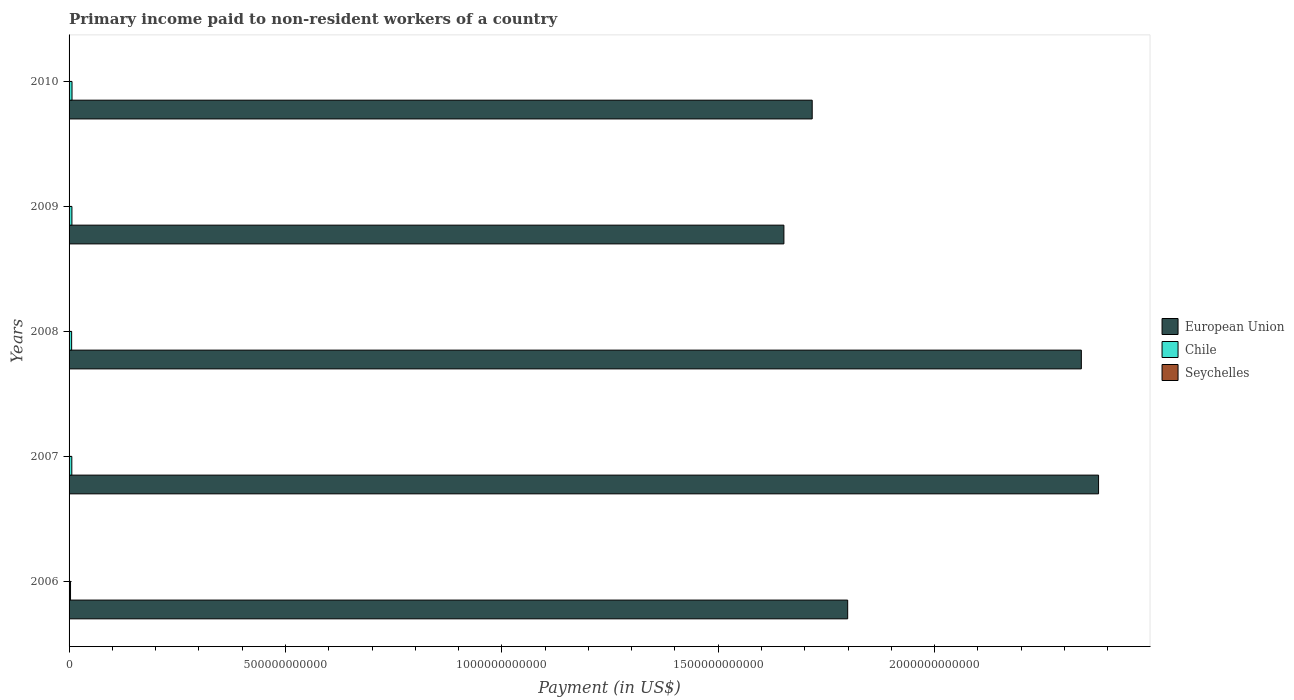How many different coloured bars are there?
Your answer should be compact. 3. How many groups of bars are there?
Make the answer very short. 5. Are the number of bars per tick equal to the number of legend labels?
Make the answer very short. Yes. How many bars are there on the 5th tick from the bottom?
Provide a succinct answer. 3. In how many cases, is the number of bars for a given year not equal to the number of legend labels?
Ensure brevity in your answer.  0. What is the amount paid to workers in Chile in 2010?
Your answer should be compact. 6.80e+09. Across all years, what is the maximum amount paid to workers in Seychelles?
Make the answer very short. 1.03e+07. Across all years, what is the minimum amount paid to workers in Chile?
Provide a short and direct response. 3.37e+09. In which year was the amount paid to workers in Chile maximum?
Ensure brevity in your answer.  2010. In which year was the amount paid to workers in Seychelles minimum?
Offer a very short reply. 2007. What is the total amount paid to workers in European Union in the graph?
Your response must be concise. 9.89e+12. What is the difference between the amount paid to workers in Chile in 2006 and that in 2007?
Your answer should be compact. -2.95e+09. What is the difference between the amount paid to workers in Seychelles in 2009 and the amount paid to workers in Chile in 2008?
Your answer should be very brief. -5.92e+09. What is the average amount paid to workers in Chile per year?
Offer a terse response. 5.80e+09. In the year 2010, what is the difference between the amount paid to workers in Seychelles and amount paid to workers in Chile?
Your response must be concise. -6.79e+09. What is the ratio of the amount paid to workers in Seychelles in 2007 to that in 2010?
Offer a very short reply. 0.37. Is the amount paid to workers in Seychelles in 2007 less than that in 2008?
Ensure brevity in your answer.  Yes. Is the difference between the amount paid to workers in Seychelles in 2008 and 2009 greater than the difference between the amount paid to workers in Chile in 2008 and 2009?
Provide a succinct answer. Yes. What is the difference between the highest and the second highest amount paid to workers in European Union?
Your answer should be very brief. 3.98e+1. What is the difference between the highest and the lowest amount paid to workers in European Union?
Your answer should be compact. 7.27e+11. In how many years, is the amount paid to workers in Seychelles greater than the average amount paid to workers in Seychelles taken over all years?
Keep it short and to the point. 2. What does the 3rd bar from the top in 2008 represents?
Your answer should be very brief. European Union. What does the 2nd bar from the bottom in 2010 represents?
Offer a terse response. Chile. How many years are there in the graph?
Offer a terse response. 5. What is the difference between two consecutive major ticks on the X-axis?
Offer a very short reply. 5.00e+11. Are the values on the major ticks of X-axis written in scientific E-notation?
Offer a very short reply. No. Does the graph contain any zero values?
Offer a terse response. No. Where does the legend appear in the graph?
Your answer should be very brief. Center right. What is the title of the graph?
Make the answer very short. Primary income paid to non-resident workers of a country. What is the label or title of the X-axis?
Your answer should be compact. Payment (in US$). What is the Payment (in US$) of European Union in 2006?
Offer a terse response. 1.80e+12. What is the Payment (in US$) of Chile in 2006?
Provide a short and direct response. 3.37e+09. What is the Payment (in US$) in Seychelles in 2006?
Provide a short and direct response. 1.03e+07. What is the Payment (in US$) of European Union in 2007?
Keep it short and to the point. 2.38e+12. What is the Payment (in US$) of Chile in 2007?
Provide a short and direct response. 6.32e+09. What is the Payment (in US$) in Seychelles in 2007?
Provide a short and direct response. 3.58e+06. What is the Payment (in US$) of European Union in 2008?
Provide a succinct answer. 2.34e+12. What is the Payment (in US$) in Chile in 2008?
Make the answer very short. 5.93e+09. What is the Payment (in US$) of Seychelles in 2008?
Ensure brevity in your answer.  4.88e+06. What is the Payment (in US$) of European Union in 2009?
Offer a very short reply. 1.65e+12. What is the Payment (in US$) of Chile in 2009?
Give a very brief answer. 6.57e+09. What is the Payment (in US$) of Seychelles in 2009?
Your answer should be compact. 3.65e+06. What is the Payment (in US$) of European Union in 2010?
Offer a very short reply. 1.72e+12. What is the Payment (in US$) of Chile in 2010?
Your answer should be compact. 6.80e+09. What is the Payment (in US$) of Seychelles in 2010?
Provide a succinct answer. 9.57e+06. Across all years, what is the maximum Payment (in US$) of European Union?
Your answer should be very brief. 2.38e+12. Across all years, what is the maximum Payment (in US$) in Chile?
Provide a short and direct response. 6.80e+09. Across all years, what is the maximum Payment (in US$) of Seychelles?
Your response must be concise. 1.03e+07. Across all years, what is the minimum Payment (in US$) in European Union?
Make the answer very short. 1.65e+12. Across all years, what is the minimum Payment (in US$) of Chile?
Your answer should be compact. 3.37e+09. Across all years, what is the minimum Payment (in US$) of Seychelles?
Ensure brevity in your answer.  3.58e+06. What is the total Payment (in US$) of European Union in the graph?
Provide a succinct answer. 9.89e+12. What is the total Payment (in US$) of Chile in the graph?
Offer a terse response. 2.90e+1. What is the total Payment (in US$) in Seychelles in the graph?
Offer a very short reply. 3.19e+07. What is the difference between the Payment (in US$) in European Union in 2006 and that in 2007?
Your answer should be compact. -5.80e+11. What is the difference between the Payment (in US$) in Chile in 2006 and that in 2007?
Offer a very short reply. -2.95e+09. What is the difference between the Payment (in US$) of Seychelles in 2006 and that in 2007?
Offer a terse response. 6.69e+06. What is the difference between the Payment (in US$) of European Union in 2006 and that in 2008?
Ensure brevity in your answer.  -5.40e+11. What is the difference between the Payment (in US$) of Chile in 2006 and that in 2008?
Offer a very short reply. -2.55e+09. What is the difference between the Payment (in US$) of Seychelles in 2006 and that in 2008?
Keep it short and to the point. 5.39e+06. What is the difference between the Payment (in US$) of European Union in 2006 and that in 2009?
Provide a short and direct response. 1.47e+11. What is the difference between the Payment (in US$) of Chile in 2006 and that in 2009?
Provide a short and direct response. -3.20e+09. What is the difference between the Payment (in US$) in Seychelles in 2006 and that in 2009?
Provide a succinct answer. 6.62e+06. What is the difference between the Payment (in US$) in European Union in 2006 and that in 2010?
Provide a short and direct response. 8.20e+1. What is the difference between the Payment (in US$) in Chile in 2006 and that in 2010?
Provide a short and direct response. -3.42e+09. What is the difference between the Payment (in US$) of Seychelles in 2006 and that in 2010?
Provide a short and direct response. 6.96e+05. What is the difference between the Payment (in US$) in European Union in 2007 and that in 2008?
Keep it short and to the point. 3.98e+1. What is the difference between the Payment (in US$) of Chile in 2007 and that in 2008?
Offer a terse response. 3.97e+08. What is the difference between the Payment (in US$) of Seychelles in 2007 and that in 2008?
Your response must be concise. -1.31e+06. What is the difference between the Payment (in US$) of European Union in 2007 and that in 2009?
Your answer should be very brief. 7.27e+11. What is the difference between the Payment (in US$) of Chile in 2007 and that in 2009?
Offer a terse response. -2.46e+08. What is the difference between the Payment (in US$) in Seychelles in 2007 and that in 2009?
Offer a very short reply. -7.35e+04. What is the difference between the Payment (in US$) in European Union in 2007 and that in 2010?
Ensure brevity in your answer.  6.62e+11. What is the difference between the Payment (in US$) in Chile in 2007 and that in 2010?
Offer a very short reply. -4.72e+08. What is the difference between the Payment (in US$) of Seychelles in 2007 and that in 2010?
Provide a short and direct response. -6.00e+06. What is the difference between the Payment (in US$) of European Union in 2008 and that in 2009?
Give a very brief answer. 6.87e+11. What is the difference between the Payment (in US$) in Chile in 2008 and that in 2009?
Give a very brief answer. -6.43e+08. What is the difference between the Payment (in US$) in Seychelles in 2008 and that in 2009?
Offer a very short reply. 1.23e+06. What is the difference between the Payment (in US$) of European Union in 2008 and that in 2010?
Ensure brevity in your answer.  6.22e+11. What is the difference between the Payment (in US$) of Chile in 2008 and that in 2010?
Offer a terse response. -8.69e+08. What is the difference between the Payment (in US$) in Seychelles in 2008 and that in 2010?
Ensure brevity in your answer.  -4.69e+06. What is the difference between the Payment (in US$) in European Union in 2009 and that in 2010?
Your response must be concise. -6.54e+1. What is the difference between the Payment (in US$) in Chile in 2009 and that in 2010?
Your answer should be very brief. -2.26e+08. What is the difference between the Payment (in US$) in Seychelles in 2009 and that in 2010?
Offer a very short reply. -5.92e+06. What is the difference between the Payment (in US$) in European Union in 2006 and the Payment (in US$) in Chile in 2007?
Provide a succinct answer. 1.79e+12. What is the difference between the Payment (in US$) of European Union in 2006 and the Payment (in US$) of Seychelles in 2007?
Give a very brief answer. 1.80e+12. What is the difference between the Payment (in US$) of Chile in 2006 and the Payment (in US$) of Seychelles in 2007?
Your answer should be compact. 3.37e+09. What is the difference between the Payment (in US$) of European Union in 2006 and the Payment (in US$) of Chile in 2008?
Make the answer very short. 1.79e+12. What is the difference between the Payment (in US$) of European Union in 2006 and the Payment (in US$) of Seychelles in 2008?
Offer a very short reply. 1.80e+12. What is the difference between the Payment (in US$) of Chile in 2006 and the Payment (in US$) of Seychelles in 2008?
Keep it short and to the point. 3.37e+09. What is the difference between the Payment (in US$) in European Union in 2006 and the Payment (in US$) in Chile in 2009?
Ensure brevity in your answer.  1.79e+12. What is the difference between the Payment (in US$) of European Union in 2006 and the Payment (in US$) of Seychelles in 2009?
Your response must be concise. 1.80e+12. What is the difference between the Payment (in US$) of Chile in 2006 and the Payment (in US$) of Seychelles in 2009?
Ensure brevity in your answer.  3.37e+09. What is the difference between the Payment (in US$) of European Union in 2006 and the Payment (in US$) of Chile in 2010?
Offer a very short reply. 1.79e+12. What is the difference between the Payment (in US$) of European Union in 2006 and the Payment (in US$) of Seychelles in 2010?
Keep it short and to the point. 1.80e+12. What is the difference between the Payment (in US$) in Chile in 2006 and the Payment (in US$) in Seychelles in 2010?
Offer a very short reply. 3.36e+09. What is the difference between the Payment (in US$) in European Union in 2007 and the Payment (in US$) in Chile in 2008?
Offer a very short reply. 2.37e+12. What is the difference between the Payment (in US$) in European Union in 2007 and the Payment (in US$) in Seychelles in 2008?
Your answer should be compact. 2.38e+12. What is the difference between the Payment (in US$) of Chile in 2007 and the Payment (in US$) of Seychelles in 2008?
Offer a very short reply. 6.32e+09. What is the difference between the Payment (in US$) of European Union in 2007 and the Payment (in US$) of Chile in 2009?
Ensure brevity in your answer.  2.37e+12. What is the difference between the Payment (in US$) of European Union in 2007 and the Payment (in US$) of Seychelles in 2009?
Your answer should be compact. 2.38e+12. What is the difference between the Payment (in US$) of Chile in 2007 and the Payment (in US$) of Seychelles in 2009?
Make the answer very short. 6.32e+09. What is the difference between the Payment (in US$) in European Union in 2007 and the Payment (in US$) in Chile in 2010?
Offer a terse response. 2.37e+12. What is the difference between the Payment (in US$) of European Union in 2007 and the Payment (in US$) of Seychelles in 2010?
Your answer should be compact. 2.38e+12. What is the difference between the Payment (in US$) of Chile in 2007 and the Payment (in US$) of Seychelles in 2010?
Your answer should be compact. 6.32e+09. What is the difference between the Payment (in US$) of European Union in 2008 and the Payment (in US$) of Chile in 2009?
Provide a short and direct response. 2.33e+12. What is the difference between the Payment (in US$) in European Union in 2008 and the Payment (in US$) in Seychelles in 2009?
Offer a very short reply. 2.34e+12. What is the difference between the Payment (in US$) of Chile in 2008 and the Payment (in US$) of Seychelles in 2009?
Offer a terse response. 5.92e+09. What is the difference between the Payment (in US$) of European Union in 2008 and the Payment (in US$) of Chile in 2010?
Provide a short and direct response. 2.33e+12. What is the difference between the Payment (in US$) in European Union in 2008 and the Payment (in US$) in Seychelles in 2010?
Offer a terse response. 2.34e+12. What is the difference between the Payment (in US$) in Chile in 2008 and the Payment (in US$) in Seychelles in 2010?
Make the answer very short. 5.92e+09. What is the difference between the Payment (in US$) of European Union in 2009 and the Payment (in US$) of Chile in 2010?
Give a very brief answer. 1.64e+12. What is the difference between the Payment (in US$) in European Union in 2009 and the Payment (in US$) in Seychelles in 2010?
Offer a terse response. 1.65e+12. What is the difference between the Payment (in US$) of Chile in 2009 and the Payment (in US$) of Seychelles in 2010?
Offer a terse response. 6.56e+09. What is the average Payment (in US$) in European Union per year?
Your response must be concise. 1.98e+12. What is the average Payment (in US$) in Chile per year?
Give a very brief answer. 5.80e+09. What is the average Payment (in US$) of Seychelles per year?
Keep it short and to the point. 6.39e+06. In the year 2006, what is the difference between the Payment (in US$) of European Union and Payment (in US$) of Chile?
Your answer should be compact. 1.80e+12. In the year 2006, what is the difference between the Payment (in US$) of European Union and Payment (in US$) of Seychelles?
Your response must be concise. 1.80e+12. In the year 2006, what is the difference between the Payment (in US$) in Chile and Payment (in US$) in Seychelles?
Keep it short and to the point. 3.36e+09. In the year 2007, what is the difference between the Payment (in US$) of European Union and Payment (in US$) of Chile?
Provide a short and direct response. 2.37e+12. In the year 2007, what is the difference between the Payment (in US$) in European Union and Payment (in US$) in Seychelles?
Provide a short and direct response. 2.38e+12. In the year 2007, what is the difference between the Payment (in US$) of Chile and Payment (in US$) of Seychelles?
Keep it short and to the point. 6.32e+09. In the year 2008, what is the difference between the Payment (in US$) of European Union and Payment (in US$) of Chile?
Your answer should be very brief. 2.33e+12. In the year 2008, what is the difference between the Payment (in US$) of European Union and Payment (in US$) of Seychelles?
Offer a very short reply. 2.34e+12. In the year 2008, what is the difference between the Payment (in US$) in Chile and Payment (in US$) in Seychelles?
Ensure brevity in your answer.  5.92e+09. In the year 2009, what is the difference between the Payment (in US$) of European Union and Payment (in US$) of Chile?
Ensure brevity in your answer.  1.65e+12. In the year 2009, what is the difference between the Payment (in US$) of European Union and Payment (in US$) of Seychelles?
Ensure brevity in your answer.  1.65e+12. In the year 2009, what is the difference between the Payment (in US$) of Chile and Payment (in US$) of Seychelles?
Offer a very short reply. 6.57e+09. In the year 2010, what is the difference between the Payment (in US$) in European Union and Payment (in US$) in Chile?
Give a very brief answer. 1.71e+12. In the year 2010, what is the difference between the Payment (in US$) of European Union and Payment (in US$) of Seychelles?
Your response must be concise. 1.72e+12. In the year 2010, what is the difference between the Payment (in US$) of Chile and Payment (in US$) of Seychelles?
Offer a very short reply. 6.79e+09. What is the ratio of the Payment (in US$) of European Union in 2006 to that in 2007?
Your response must be concise. 0.76. What is the ratio of the Payment (in US$) of Chile in 2006 to that in 2007?
Offer a very short reply. 0.53. What is the ratio of the Payment (in US$) of Seychelles in 2006 to that in 2007?
Keep it short and to the point. 2.87. What is the ratio of the Payment (in US$) of European Union in 2006 to that in 2008?
Your answer should be very brief. 0.77. What is the ratio of the Payment (in US$) in Chile in 2006 to that in 2008?
Make the answer very short. 0.57. What is the ratio of the Payment (in US$) of Seychelles in 2006 to that in 2008?
Offer a terse response. 2.1. What is the ratio of the Payment (in US$) of European Union in 2006 to that in 2009?
Your response must be concise. 1.09. What is the ratio of the Payment (in US$) of Chile in 2006 to that in 2009?
Keep it short and to the point. 0.51. What is the ratio of the Payment (in US$) of Seychelles in 2006 to that in 2009?
Give a very brief answer. 2.81. What is the ratio of the Payment (in US$) in European Union in 2006 to that in 2010?
Offer a terse response. 1.05. What is the ratio of the Payment (in US$) in Chile in 2006 to that in 2010?
Provide a short and direct response. 0.5. What is the ratio of the Payment (in US$) in Seychelles in 2006 to that in 2010?
Provide a short and direct response. 1.07. What is the ratio of the Payment (in US$) in European Union in 2007 to that in 2008?
Your answer should be compact. 1.02. What is the ratio of the Payment (in US$) in Chile in 2007 to that in 2008?
Give a very brief answer. 1.07. What is the ratio of the Payment (in US$) in Seychelles in 2007 to that in 2008?
Keep it short and to the point. 0.73. What is the ratio of the Payment (in US$) in European Union in 2007 to that in 2009?
Offer a very short reply. 1.44. What is the ratio of the Payment (in US$) in Chile in 2007 to that in 2009?
Provide a succinct answer. 0.96. What is the ratio of the Payment (in US$) in Seychelles in 2007 to that in 2009?
Your answer should be compact. 0.98. What is the ratio of the Payment (in US$) of European Union in 2007 to that in 2010?
Your answer should be compact. 1.39. What is the ratio of the Payment (in US$) in Chile in 2007 to that in 2010?
Provide a succinct answer. 0.93. What is the ratio of the Payment (in US$) of Seychelles in 2007 to that in 2010?
Keep it short and to the point. 0.37. What is the ratio of the Payment (in US$) of European Union in 2008 to that in 2009?
Ensure brevity in your answer.  1.42. What is the ratio of the Payment (in US$) of Chile in 2008 to that in 2009?
Provide a short and direct response. 0.9. What is the ratio of the Payment (in US$) of Seychelles in 2008 to that in 2009?
Provide a succinct answer. 1.34. What is the ratio of the Payment (in US$) in European Union in 2008 to that in 2010?
Keep it short and to the point. 1.36. What is the ratio of the Payment (in US$) in Chile in 2008 to that in 2010?
Offer a terse response. 0.87. What is the ratio of the Payment (in US$) of Seychelles in 2008 to that in 2010?
Your answer should be very brief. 0.51. What is the ratio of the Payment (in US$) of European Union in 2009 to that in 2010?
Give a very brief answer. 0.96. What is the ratio of the Payment (in US$) of Chile in 2009 to that in 2010?
Make the answer very short. 0.97. What is the ratio of the Payment (in US$) of Seychelles in 2009 to that in 2010?
Provide a short and direct response. 0.38. What is the difference between the highest and the second highest Payment (in US$) of European Union?
Give a very brief answer. 3.98e+1. What is the difference between the highest and the second highest Payment (in US$) of Chile?
Give a very brief answer. 2.26e+08. What is the difference between the highest and the second highest Payment (in US$) of Seychelles?
Your response must be concise. 6.96e+05. What is the difference between the highest and the lowest Payment (in US$) of European Union?
Give a very brief answer. 7.27e+11. What is the difference between the highest and the lowest Payment (in US$) of Chile?
Make the answer very short. 3.42e+09. What is the difference between the highest and the lowest Payment (in US$) of Seychelles?
Make the answer very short. 6.69e+06. 